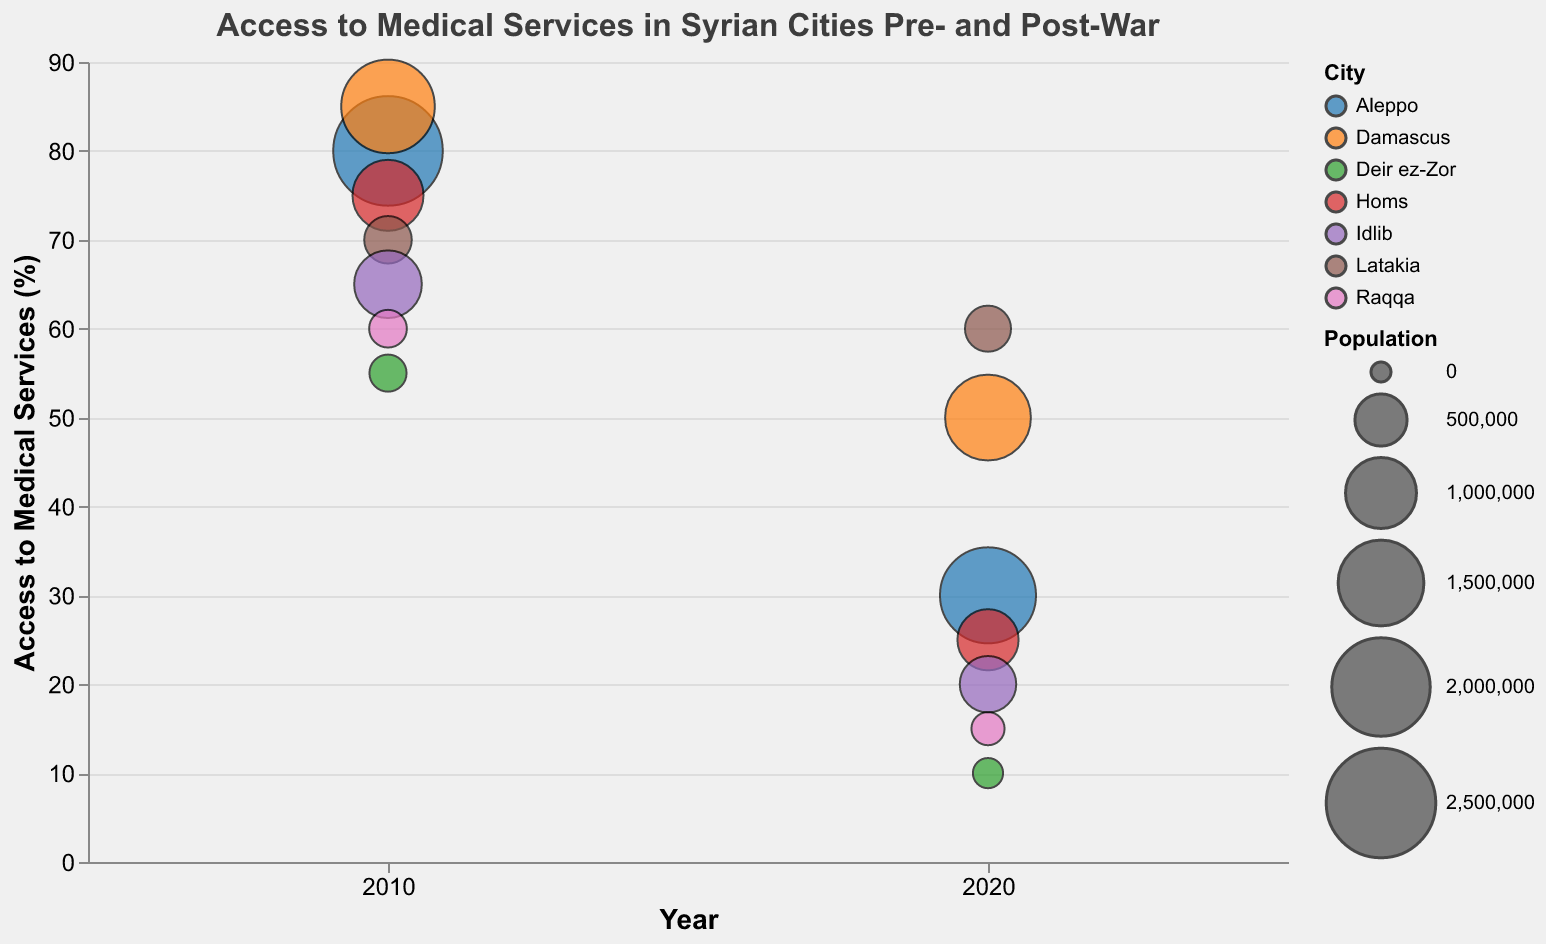What's the title of the bubble chart? The title is displayed at the top of the chart. It reads "Access to Medical Services in Syrian Cities Pre- and Post-War".
Answer: Access to Medical Services in Syrian Cities Pre- and Post-War Which city had the highest access to medical services in 2010? Look at the y-axis and find the bubble with the highest y-value in 2010. This corresponds to Damascus with an access level of 85%.
Answer: Damascus What is the population of Aleppo in 2020? Hover over the bubble for Aleppo in 2020 to see the tooltip. It shows the population as 1,900,000.
Answer: 1,900,000 How much did the access to medical services in Homs decrease from 2010 to 2020? Subtract the access percentage of Homs in 2020 from that in 2010. The decrease is from 75% to 25%. So, 75% - 25% = 50%.
Answer: 50% Which city saw the smallest decline in access to medical services from 2010 to 2020? Compare the difference in access to medical services for all cities. Latakia's access decreased from 70% to 60%, which is a decline of 10%, the smallest among all cities.
Answer: Latakia Which city had the smallest population in 2020? The bubble with the smallest size in 2020 indicates the smallest population. This corresponds to Deir ez-Zor with a population of 110,000.
Answer: Deir ez-Zor What was the access to medical services in Raqqa in 2010 and 2020? Check the position of Raqqa's bubbles along the y-axis for both years. In 2010, it was 60%, and in 2020, it was 15%.
Answer: 60% in 2010 and 15% in 2020 How many cities are there in the data set? Count the distinct colors representing each city in the legend or bubbles, there are 7 cities.
Answer: 7 Which city had the highest population in 2020? The largest bubble size in 2020 corresponds to Aleppo with a population of 1,900,000.
Answer: Aleppo What was the average access to medical services across all cities in 2020? Add the access percentages for all cities in 2020 and divide by the number of cities. (30 + 50 + 25 + 60 + 20 + 15 + 10) / 7 = 30.
Answer: 30 